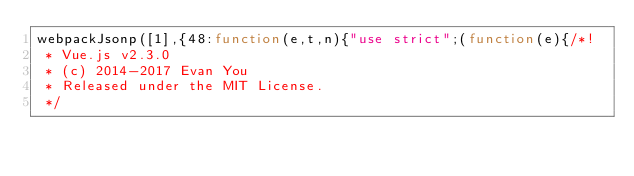<code> <loc_0><loc_0><loc_500><loc_500><_JavaScript_>webpackJsonp([1],{48:function(e,t,n){"use strict";(function(e){/*!
 * Vue.js v2.3.0
 * (c) 2014-2017 Evan You
 * Released under the MIT License.
 */</code> 